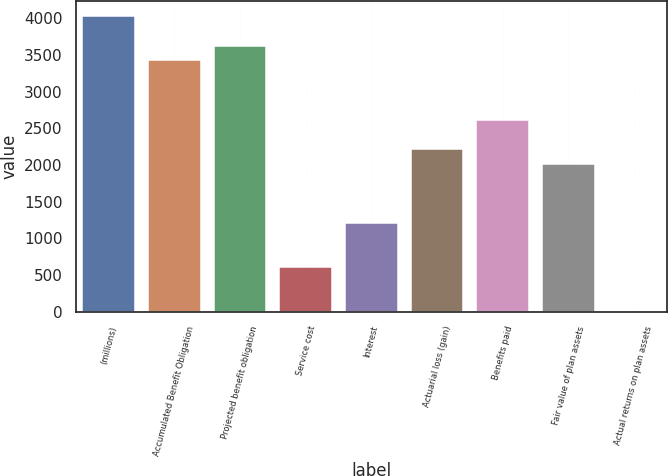<chart> <loc_0><loc_0><loc_500><loc_500><bar_chart><fcel>(millions)<fcel>Accumulated Benefit Obligation<fcel>Projected benefit obligation<fcel>Service cost<fcel>Interest<fcel>Actuarial loss (gain)<fcel>Benefits paid<fcel>Fair value of plan assets<fcel>Actual returns on plan assets<nl><fcel>4029.9<fcel>3425.43<fcel>3626.92<fcel>604.57<fcel>1209.04<fcel>2216.49<fcel>2619.47<fcel>2015<fcel>0.1<nl></chart> 